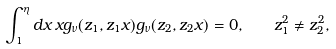<formula> <loc_0><loc_0><loc_500><loc_500>\int _ { 1 } ^ { \eta } d x \, x g _ { \nu } ( z _ { 1 } , z _ { 1 } x ) g _ { \nu } ( z _ { 2 } , z _ { 2 } x ) = 0 , \quad z _ { 1 } ^ { 2 } \neq z _ { 2 } ^ { 2 } ,</formula> 